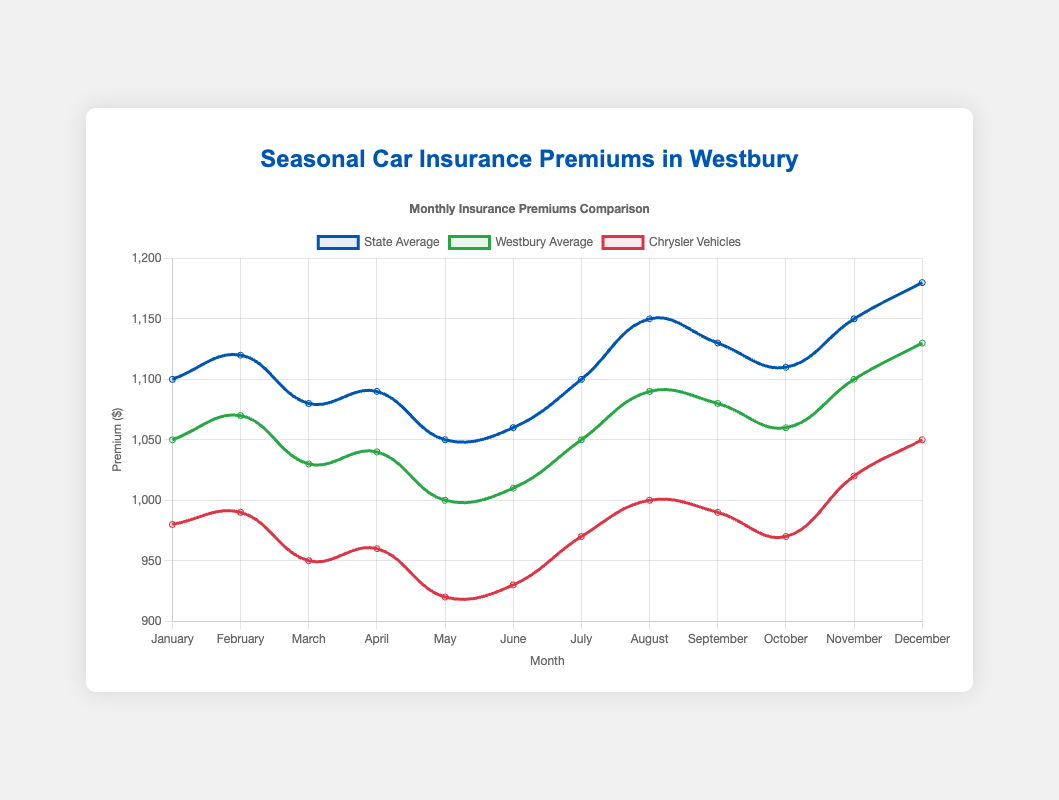What is the difference in car insurance premiums for Chrysler vehicles between December and January? To find the difference, we need to subtract the January premium from the December premium (1050 - 980).
Answer: 70 In which month is the insurance premium for Chrysler vehicles the lowest? By looking at the data, we can see that May has the lowest premium at 920.
Answer: May How does the insurance premium for Chrysler vehicles in March compare to the state average in March? The premium for Chrysler vehicles in March is 950, while the state average is 1080. Comparing them, 950 is less than 1080.
Answer: Less Which month shows the highest state average for insurance premiums? Looking at the data, December has the highest state average at 1180.
Answer: December What is the average insurance premium for Chrysler vehicles over the year? To find the average, sum all premiums for Chrysler vehicles and divide by 12: (980 + 990 + 950 + 960 + 920 + 930 + 970 + 1000 + 990 + 970 + 1020 + 1050) / 12 = 973.33
Answer: 973.33 Which month has the smallest gap between the state average and the Westbury average? The smallest gap is found in January. The difference is 50 (1100 - 1050).
Answer: January How many months do chryslers premiums remain below 1000? By counting the months, we see January (980), February (990), March (950), April (960), May (920), June (930), July (970), September (990), and October (970), totaling 9 months.
Answer: 9 If the premium for Chrysler vehicles in April increased by 50, would it still be less than the state average for the same month? Increasing the April premium by 50 gives 960 + 50 = 1010, which is still less than the state average of 1090 for that month.
Answer: Yes 